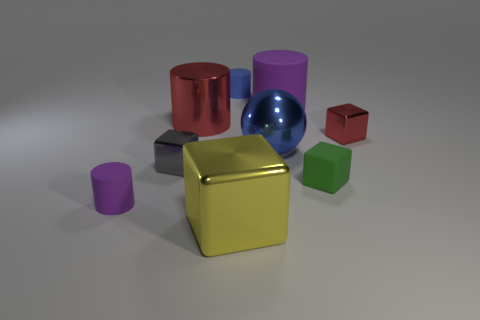Subtract all large red cylinders. How many cylinders are left? 3 Subtract all yellow blocks. How many purple cylinders are left? 2 Add 1 red things. How many objects exist? 10 Subtract all yellow blocks. How many blocks are left? 3 Subtract 1 cylinders. How many cylinders are left? 3 Add 2 red cylinders. How many red cylinders are left? 3 Add 4 large yellow shiny cylinders. How many large yellow shiny cylinders exist? 4 Subtract 0 purple spheres. How many objects are left? 9 Subtract all cylinders. How many objects are left? 5 Subtract all blue cylinders. Subtract all red cubes. How many cylinders are left? 3 